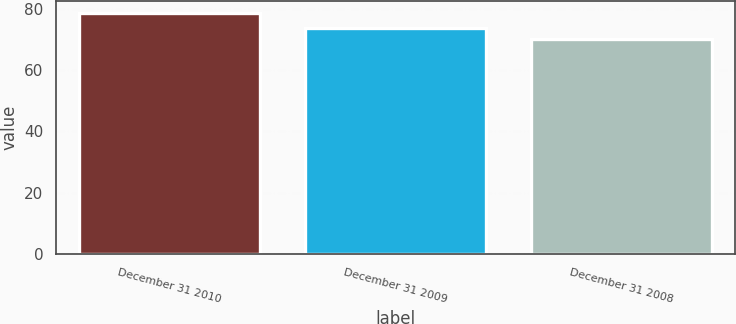Convert chart to OTSL. <chart><loc_0><loc_0><loc_500><loc_500><bar_chart><fcel>December 31 2010<fcel>December 31 2009<fcel>December 31 2008<nl><fcel>78.7<fcel>73.8<fcel>70.3<nl></chart> 